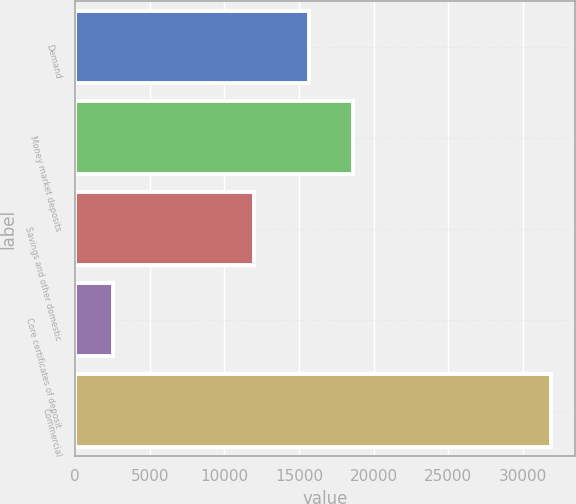Convert chart. <chart><loc_0><loc_0><loc_500><loc_500><bar_chart><fcel>Demand<fcel>Money market deposits<fcel>Savings and other domestic<fcel>Core certificates of deposit<fcel>Commercial<nl><fcel>15676<fcel>18611.2<fcel>11975<fcel>2535<fcel>31887<nl></chart> 